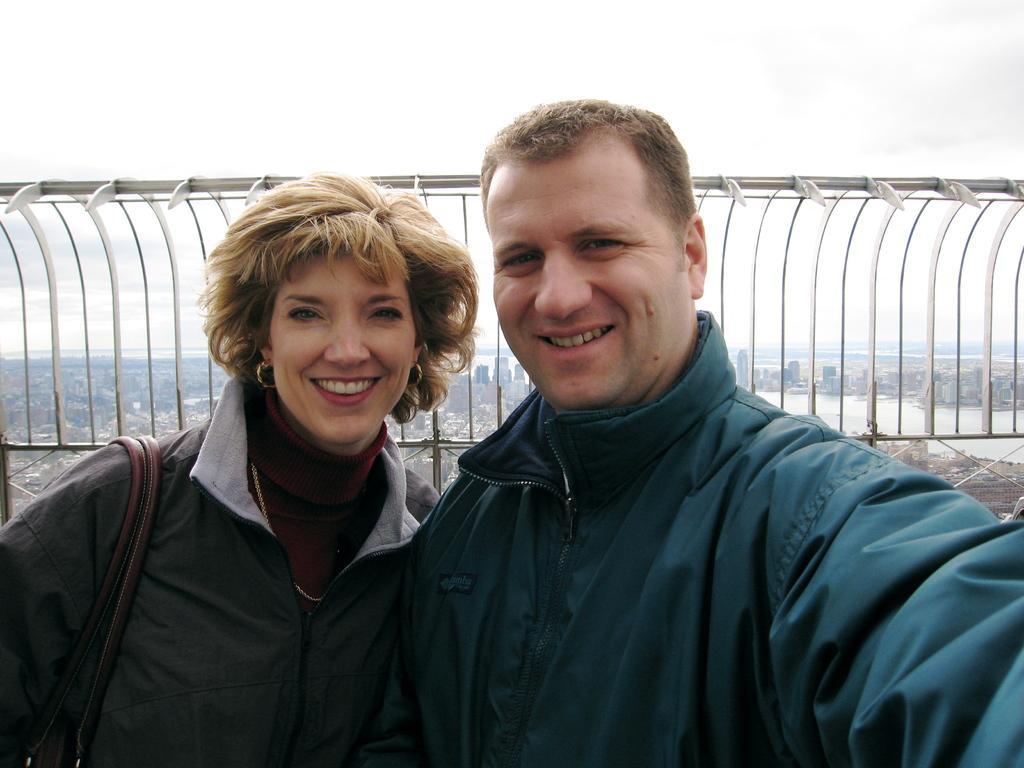Could you give a brief overview of what you see in this image? This is the man and woman standing and smiling. They wore jerkins. This looks like an iron grill. In the background, I can see the video of the city with the buildings. This looks like a river with the water flowing. 